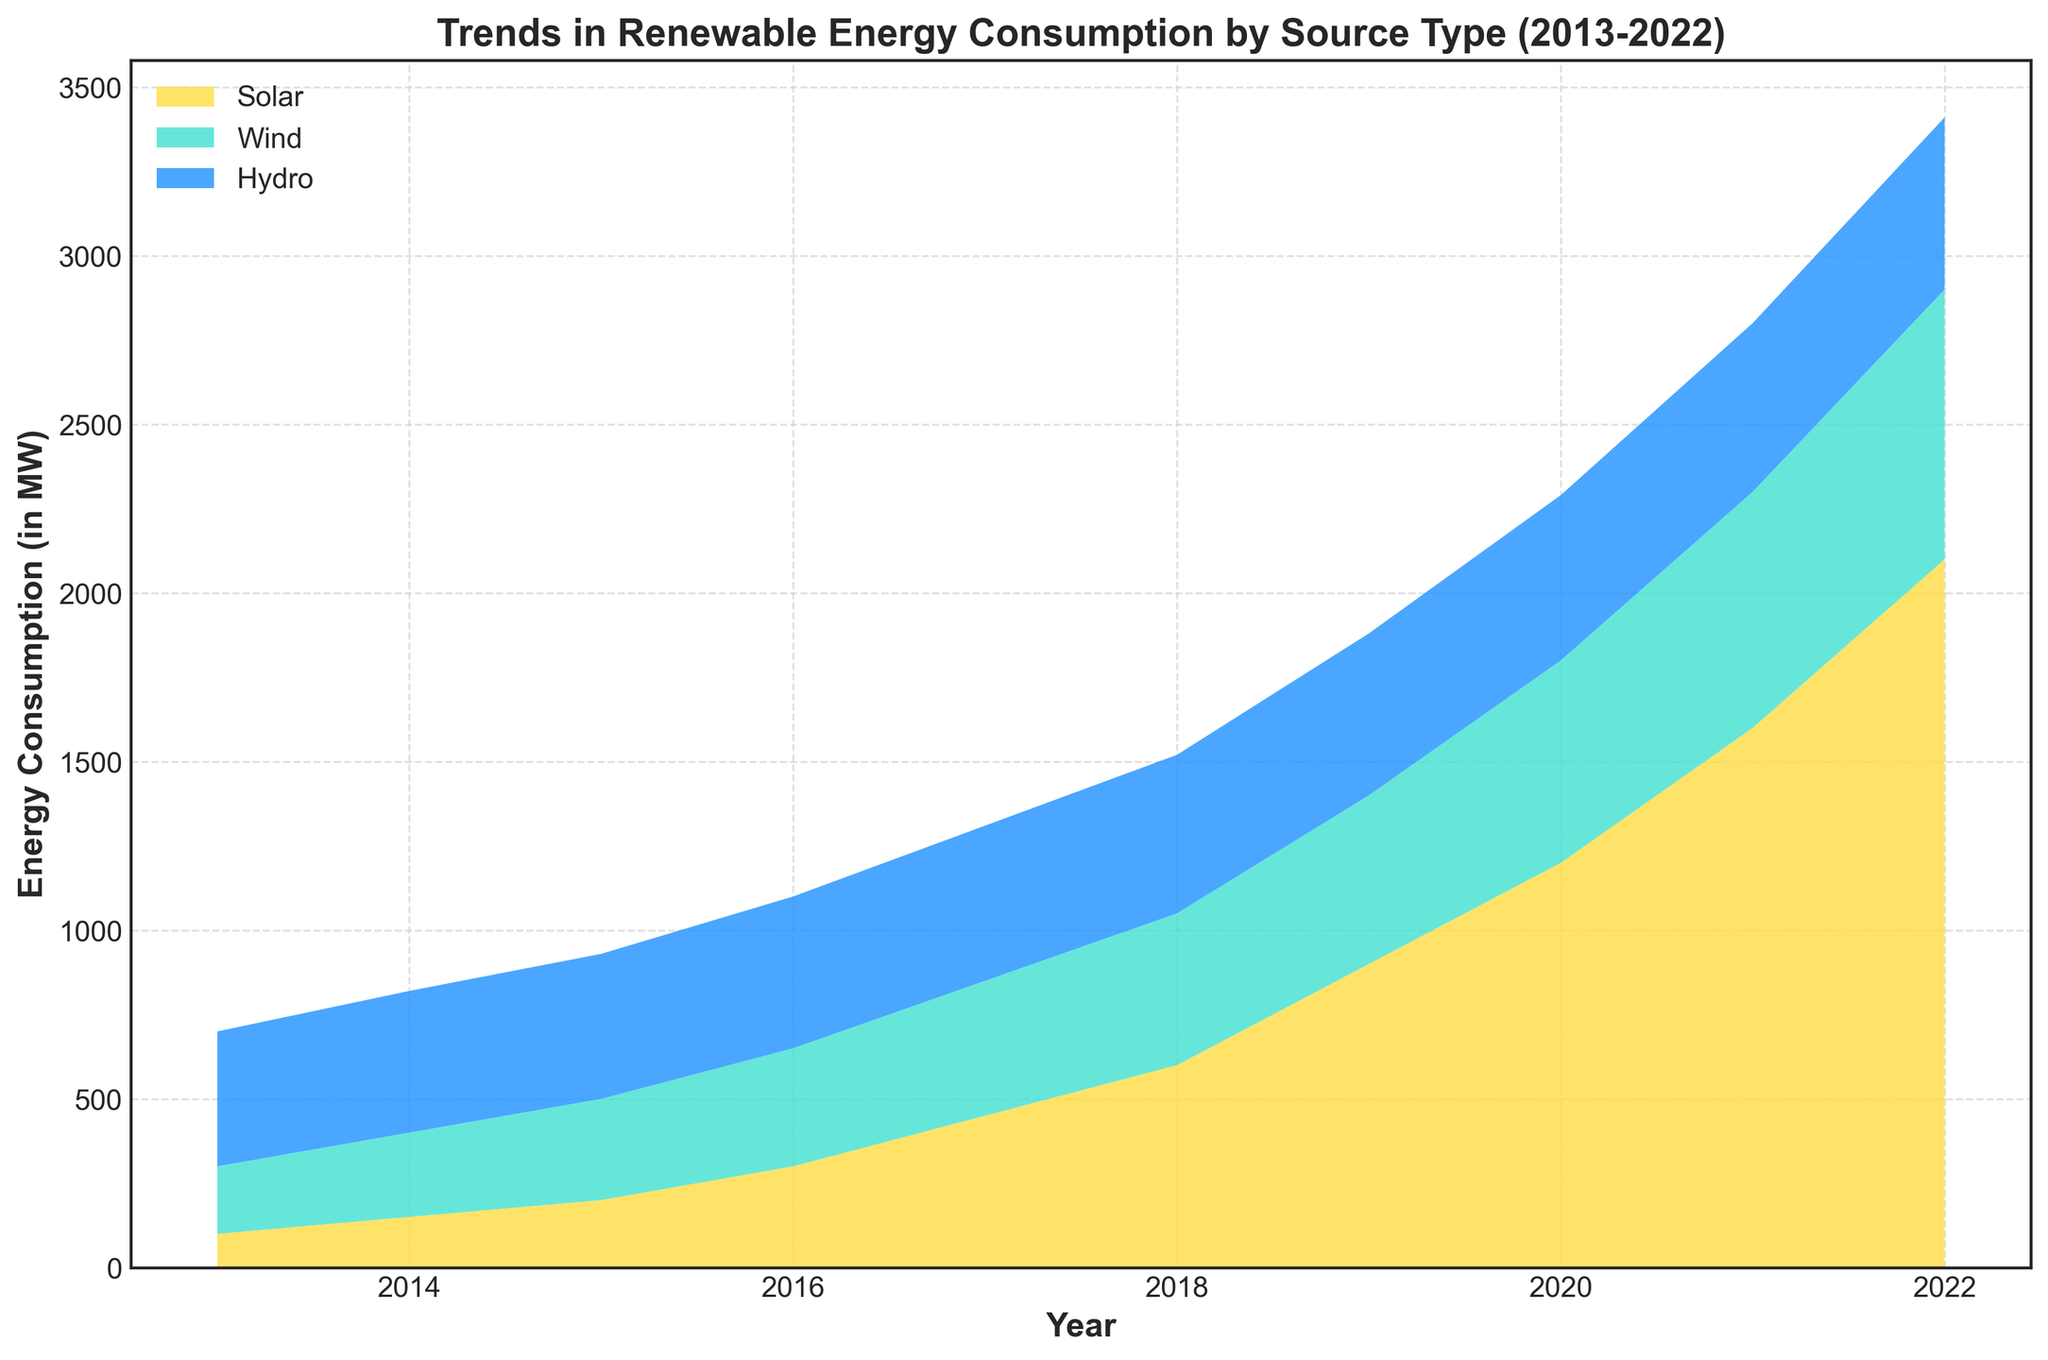How much more energy did solar consume in 2022 compared to 2017? In 2022, solar energy consumption was 2100 MW, and in 2017, it was 450 MW. Subtracting 450 from 2100 gives the increased amount, which is 2100 - 450 = 1650 MW.
Answer: 1650 MW Which renewable energy source showed the most significant increase in consumption over the past decade? By comparing the increase from 2013 to 2022 for each source: solar (100 MW to 2100 MW), wind (200 MW to 800 MW), and hydro (400 MW to 510 MW). Solar shows the most significant increase as it grew by 2000 MW.
Answer: Solar In which year did wind energy consumption reach 500 MW? Observing the stackplot, wind energy consumption reached 500 MW in the year 2019.
Answer: 2019 What is the total renewable energy consumption combining all sources in the year 2020? Summing the values for solar (1200 MW), wind (600 MW), and hydro (490 MW) in 2020; Total = 1200 + 600 + 490 = 2290 MW.
Answer: 2290 MW By how much did hydro energy consumption increase from 2013 to 2022? Hydro energy consumption increased from 400 MW in 2013 to 510 MW in 2022. 510 - 400 = 110 MW.
Answer: 110 MW Which year saw the largest single-year increase in solar energy consumption? By examining the step increases in the solar energy plot, the largest single-year increase occurred from 2019 (900 MW) to 2020 (1200 MW), which is 1200 - 900 = 300 MW.
Answer: 2019 to 2020 What is the average wind energy consumption over the entire decade? Summing the wind energy consumption values provided and dividing by the number of years: (200 + 250 + 300 + 350 + 400 + 450 + 500 + 600 + 700 + 800) / 10 = 455 MW
Answer: 455 MW In which year did total renewable energy consumption surpass 2000 MW for the first time? Analyzing the cumulative stack plot, total renewable energy consumption first surpassed 2000 MW in 2019 when the sum of solar (900 MW), wind (500 MW), and hydro (480 MW) equaled 1880 MW. Thus, it surpassed in 2020 with 1200 (solar) + 600 (wind) + 490 (hydro) = 2290 MW.
Answer: 2020 Between wind and hydro energy in 2015, which showed a higher consumption and by how much? In 2015, wind energy was at 300 MW and hydro energy at 430 MW. Hydro was higher by 430 - 300 = 130 MW.
Answer: Hydro, 130 MW 